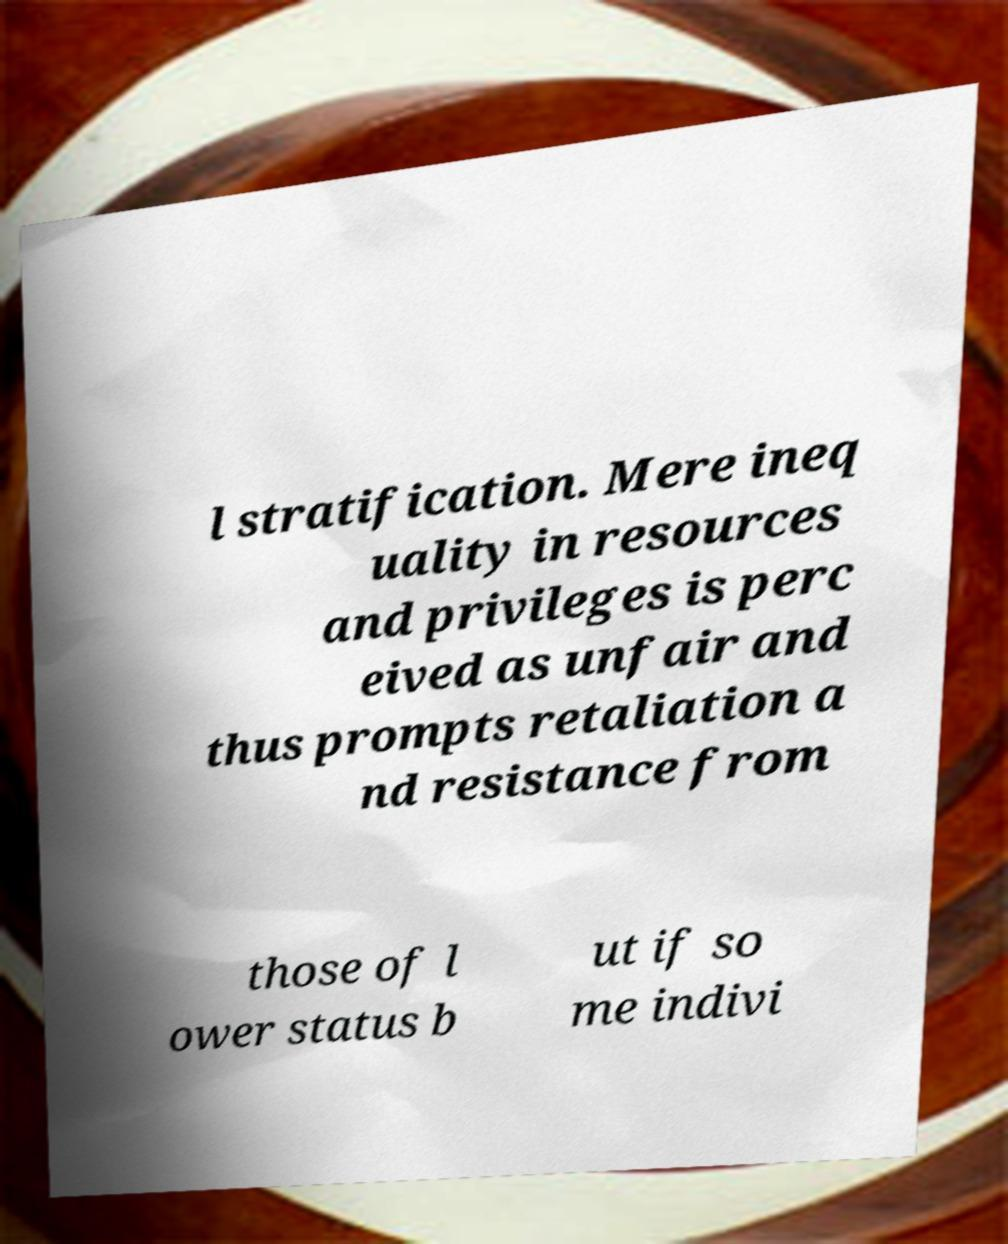Can you read and provide the text displayed in the image?This photo seems to have some interesting text. Can you extract and type it out for me? l stratification. Mere ineq uality in resources and privileges is perc eived as unfair and thus prompts retaliation a nd resistance from those of l ower status b ut if so me indivi 